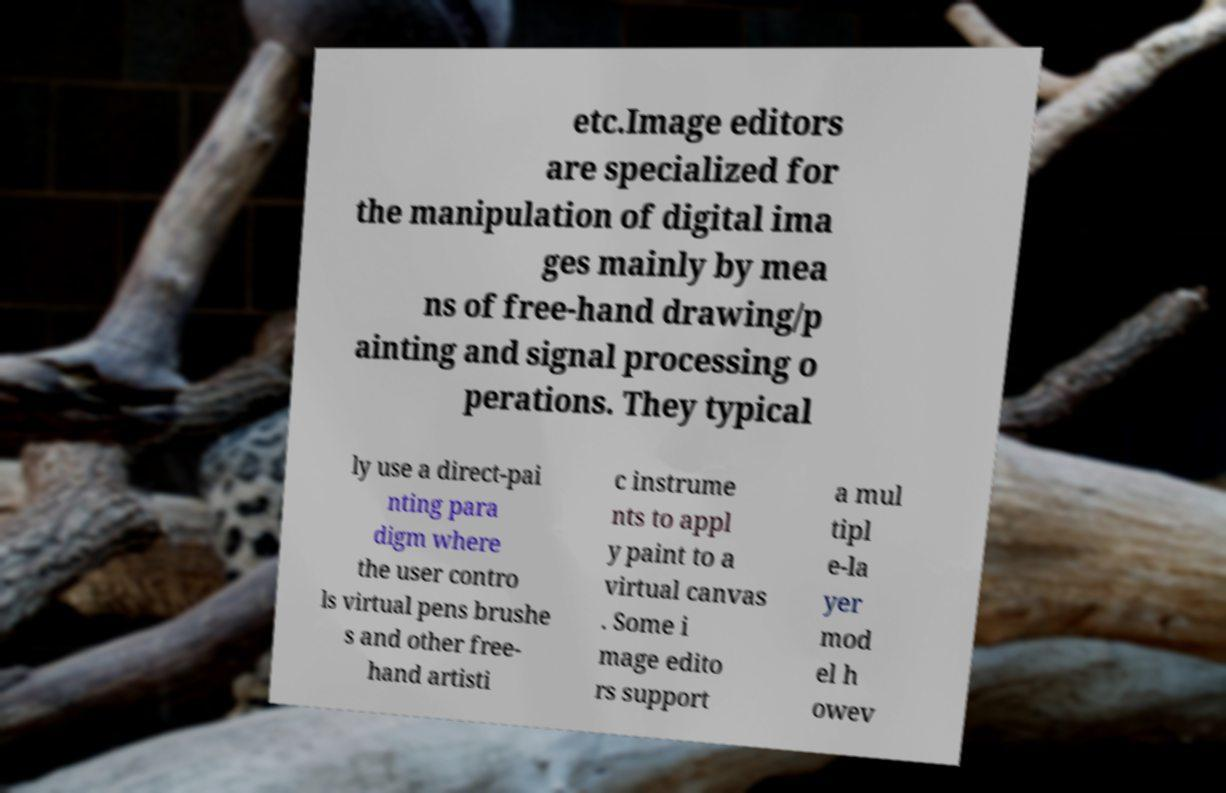I need the written content from this picture converted into text. Can you do that? etc.Image editors are specialized for the manipulation of digital ima ges mainly by mea ns of free-hand drawing/p ainting and signal processing o perations. They typical ly use a direct-pai nting para digm where the user contro ls virtual pens brushe s and other free- hand artisti c instrume nts to appl y paint to a virtual canvas . Some i mage edito rs support a mul tipl e-la yer mod el h owev 